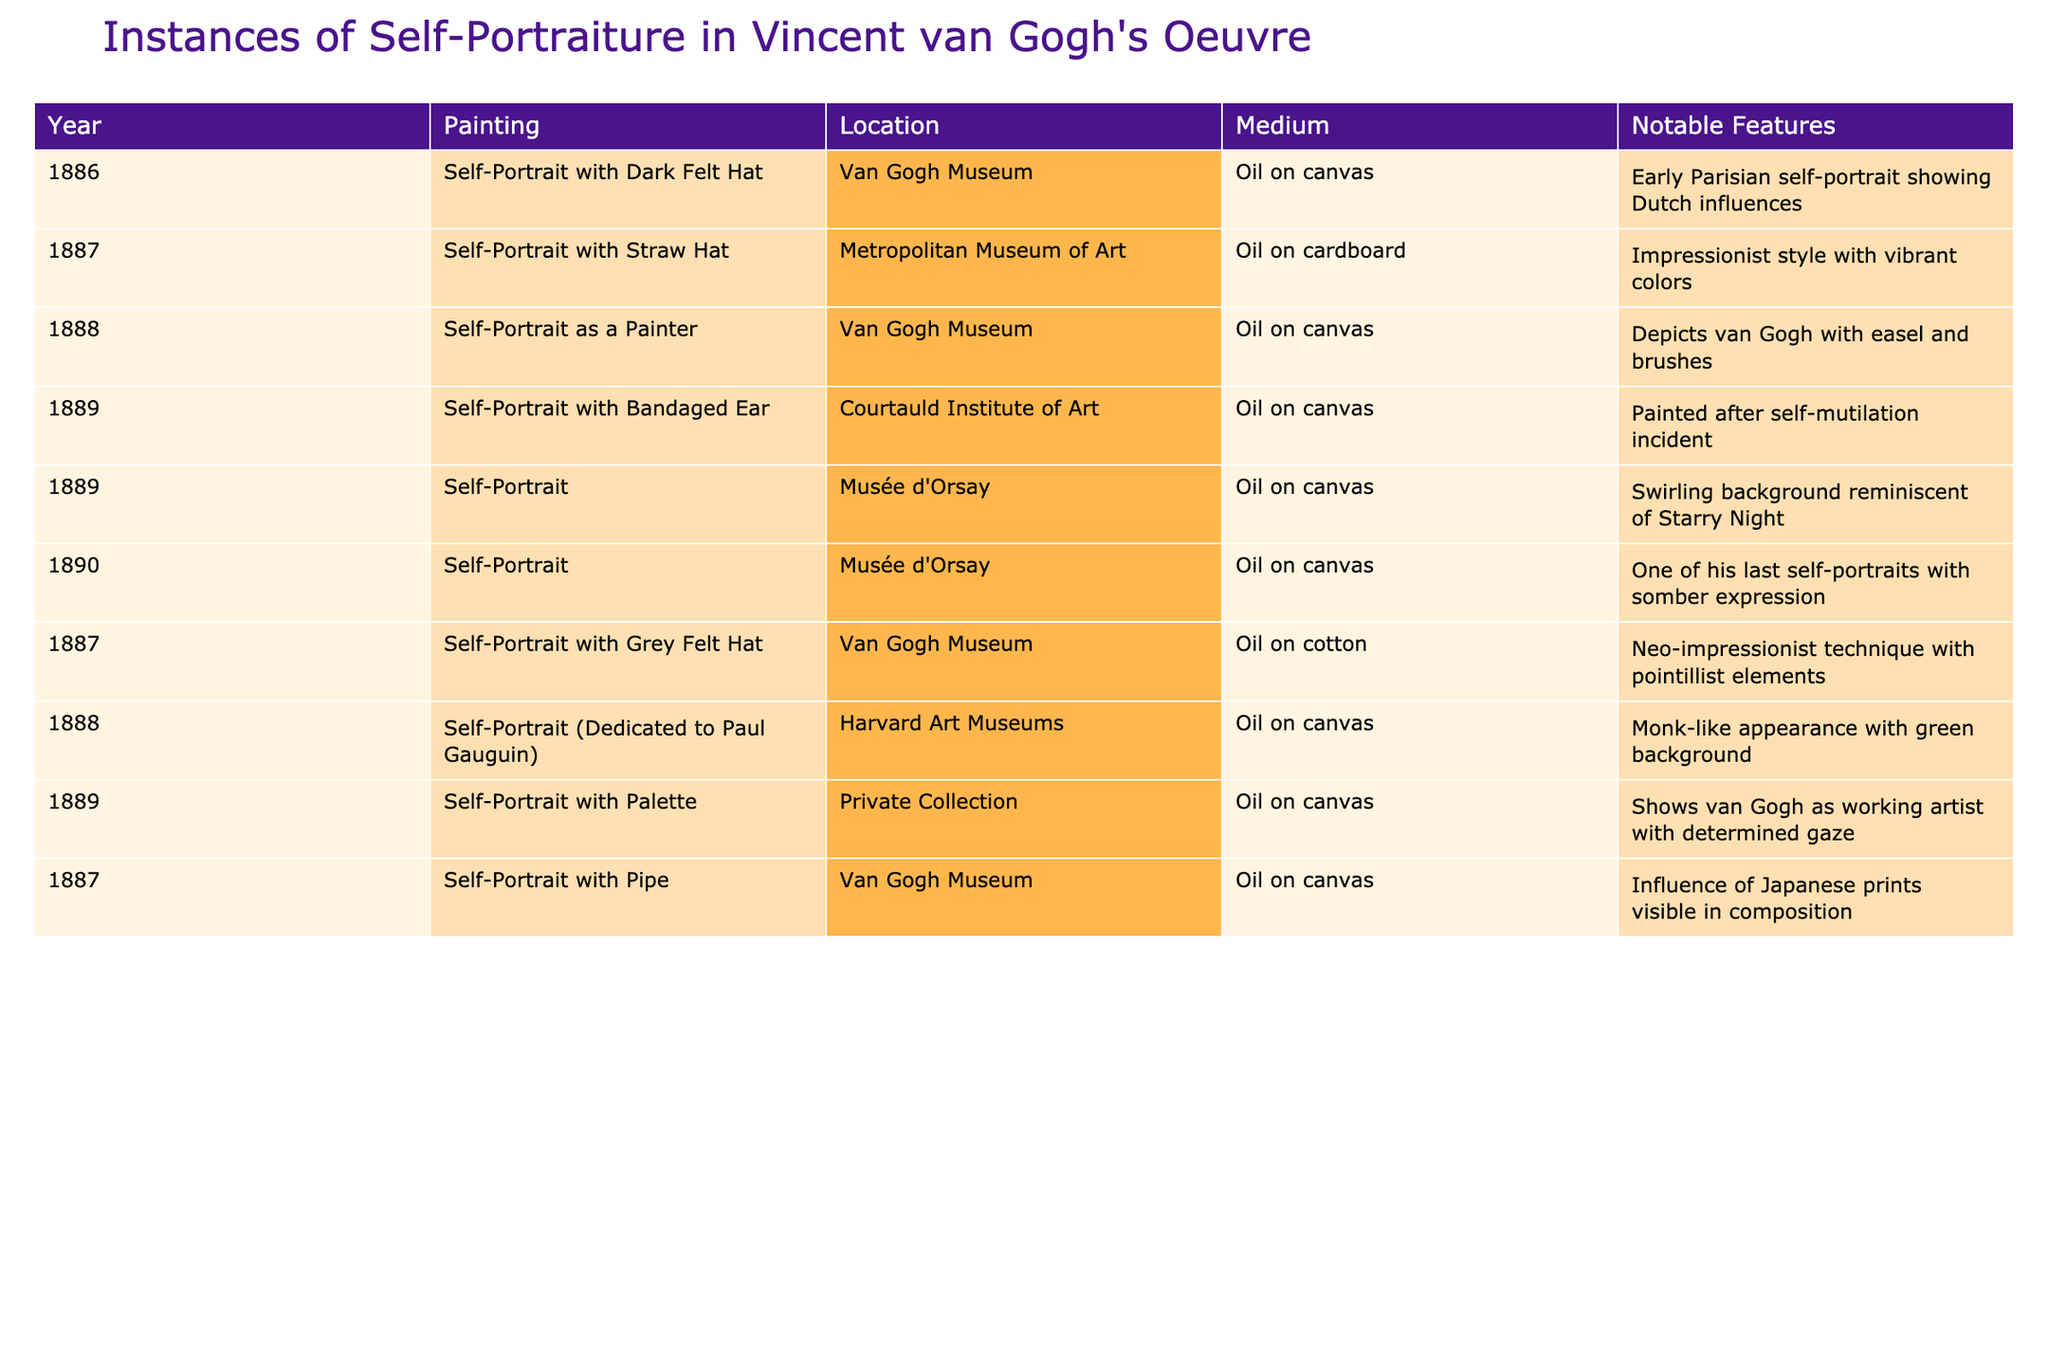What is the total number of self-portraits listed in the table? The table lists a total of 9 entries for self-portraits.
Answer: 9 In which year did Vincent van Gogh create the painting "Self-Portrait with Bandaged Ear"? According to the table, Vincent van Gogh created "Self-Portrait with Bandaged Ear" in 1889.
Answer: 1889 What is the primary medium used for all the self-portraits in the table? The table indicates that all the self-portraits listed are created using oil on canvas or oil on cardboard, making oil the primary medium.
Answer: Oil Which painting was created in 1888 and features a monk-like appearance? The painting created in 1888 featuring a monk-like appearance is "Self-Portrait (Dedicated to Paul Gauguin)."
Answer: Self-Portrait (Dedicated to Paul Gauguin) How many self-portraits were created after the year 1887? By counting the entries from 1888 to 1890, there are 5 self-portraits created after 1887.
Answer: 5 Is "Self-Portrait with Grey Felt Hat" made using oil on canvas? The table shows that "Self-Portrait with Grey Felt Hat" is made on oil on cotton, which means the statement is false.
Answer: No What notable feature is common between "Self-Portrait with Bandaged Ear" and "Self-Portrait"? Both paintings were created in 1889; the notable feature common is that they reflect a turbulent period in van Gogh's life, with personal struggles depicted in the artwork.
Answer: Turbulent period reflection Which two self-portraits were created in the same year, 1887? The two self-portraits created in 1887 are "Self-Portrait with Straw Hat" and "Self-Portrait with Grey Felt Hat."
Answer: Self-Portrait with Straw Hat, Self-Portrait with Grey Felt Hat Which painting has a swirling background reminiscent of "Starry Night"? The painting with a swirling background reminiscent of "Starry Night" is titled "Self-Portrait."
Answer: Self-Portrait What notable feature distinguishes "Self-Portrait with Palette" from other self-portraits in the table? "Self-Portrait with Palette" shows van Gogh as a working artist with a determined gaze, distinguishing it from others that have more personal or emotive attributes.
Answer: Working artist depiction 